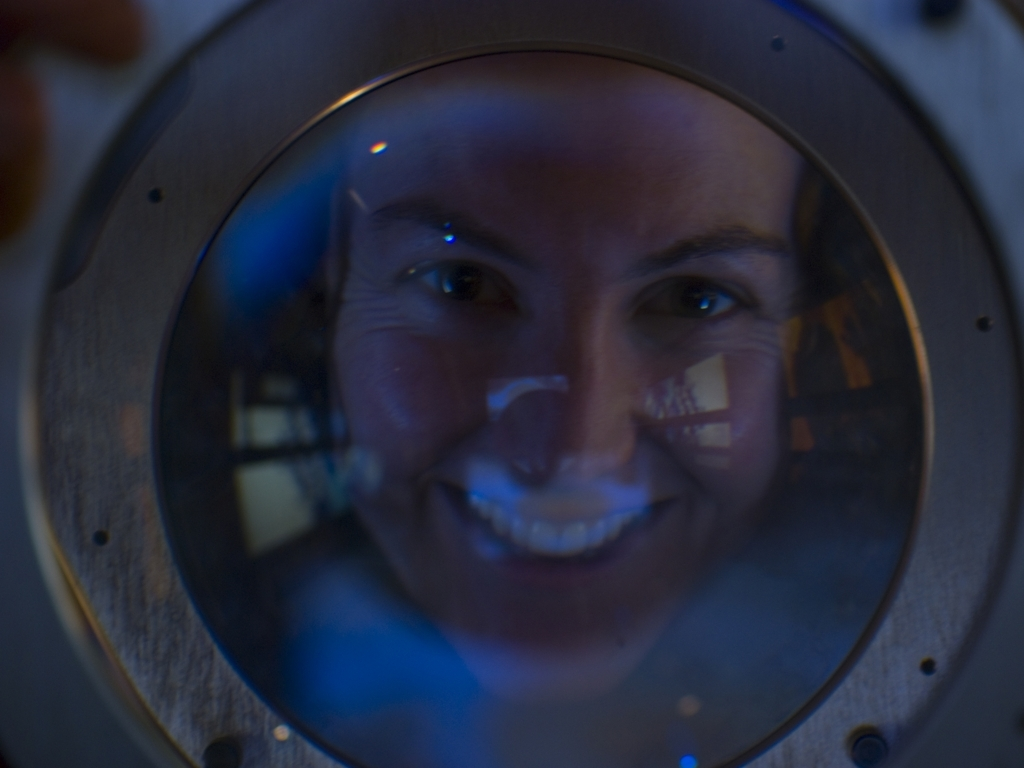What effect has been used to create the unique visual perspective in this image? The image showcases an individual's face viewed through a circular, possibly glass or transparent surface which is distorting the image, creating an intriguing visual effect that plays with the viewer's perception, often associated with peering through a lens or a rounded viewing portal. 